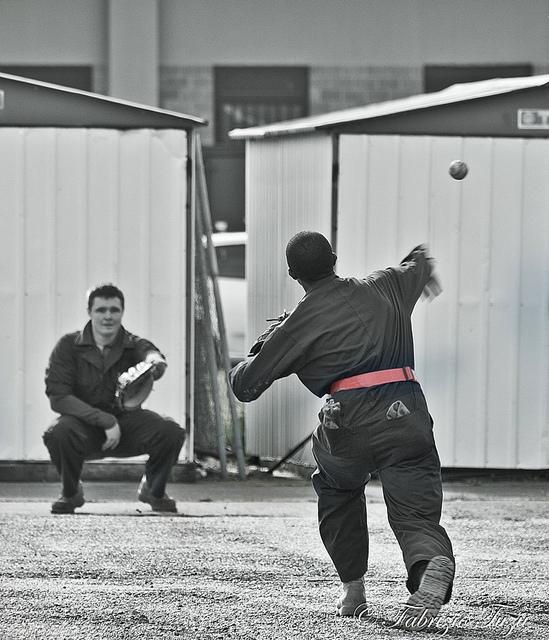Which sport is this?
Keep it brief. Baseball. What color is the picture?
Be succinct. Black and white. What color are the men wearing?
Give a very brief answer. Black. 